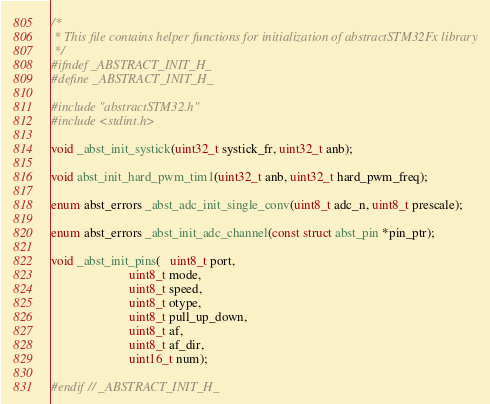Convert code to text. <code><loc_0><loc_0><loc_500><loc_500><_C_>/*
 * This file contains helper functions for initialization of abstractSTM32Fx library
 */
#ifndef _ABSTRACT_INIT_H_
#define _ABSTRACT_INIT_H_

#include "abstractSTM32.h"
#include <stdint.h>

void _abst_init_systick(uint32_t systick_fr, uint32_t anb);

void abst_init_hard_pwm_tim1(uint32_t anb, uint32_t hard_pwm_freq);

enum abst_errors _abst_adc_init_single_conv(uint8_t adc_n, uint8_t prescale);

enum abst_errors _abst_init_adc_channel(const struct abst_pin *pin_ptr);

void _abst_init_pins(   uint8_t port, 
                        uint8_t mode, 
                        uint8_t speed, 
                        uint8_t otype, 
                        uint8_t pull_up_down,
                        uint8_t af,
                        uint8_t af_dir,
                        uint16_t num);

#endif // _ABSTRACT_INIT_H_
</code> 